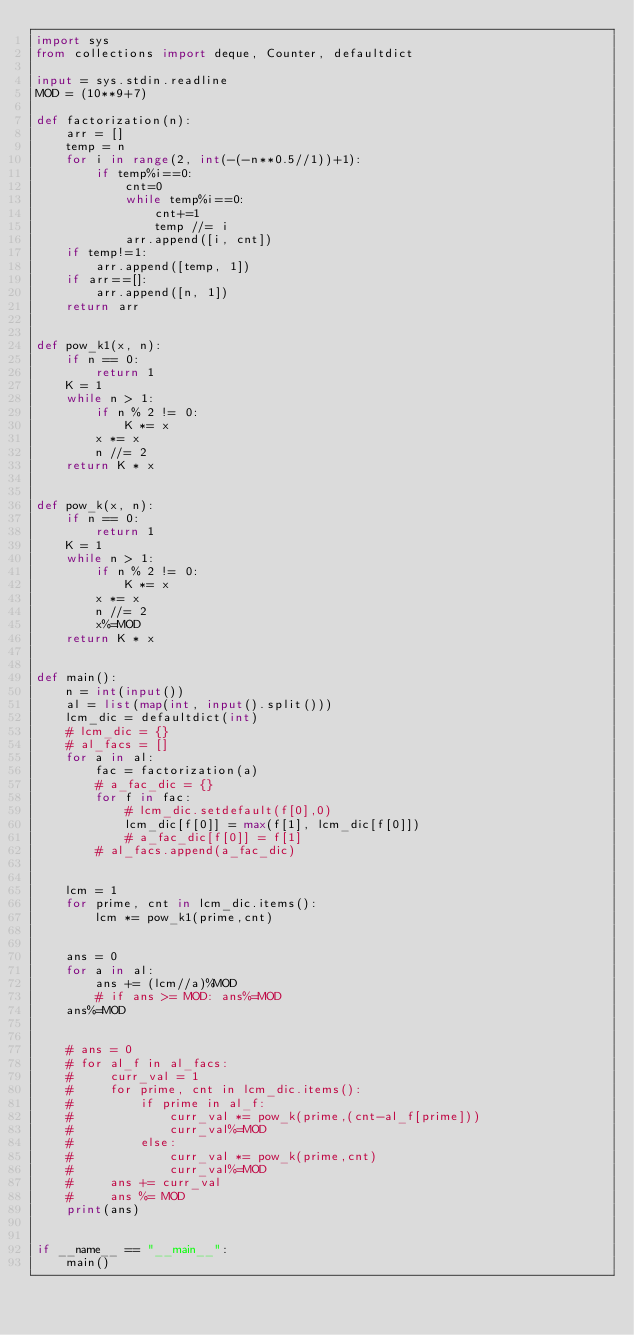<code> <loc_0><loc_0><loc_500><loc_500><_Python_>import sys
from collections import deque, Counter, defaultdict

input = sys.stdin.readline
MOD = (10**9+7)

def factorization(n):
    arr = []
    temp = n
    for i in range(2, int(-(-n**0.5//1))+1):
        if temp%i==0:
            cnt=0
            while temp%i==0:
                cnt+=1
                temp //= i
            arr.append([i, cnt])
    if temp!=1:
        arr.append([temp, 1])
    if arr==[]:
        arr.append([n, 1])
    return arr


def pow_k1(x, n):
    if n == 0:
        return 1
    K = 1
    while n > 1:
        if n % 2 != 0:
            K *= x
        x *= x
        n //= 2
    return K * x


def pow_k(x, n):
    if n == 0:
        return 1
    K = 1
    while n > 1:
        if n % 2 != 0:
            K *= x
        x *= x
        n //= 2
        x%=MOD
    return K * x


def main():
    n = int(input())
    al = list(map(int, input().split())) 
    lcm_dic = defaultdict(int)
    # lcm_dic = {}
    # al_facs = []
    for a in al:
        fac = factorization(a)
        # a_fac_dic = {}
        for f in fac:
            # lcm_dic.setdefault(f[0],0)
            lcm_dic[f[0]] = max(f[1], lcm_dic[f[0]])
            # a_fac_dic[f[0]] = f[1]
        # al_facs.append(a_fac_dic)


    lcm = 1
    for prime, cnt in lcm_dic.items():
        lcm *= pow_k1(prime,cnt)

    
    ans = 0
    for a in al:
        ans += (lcm//a)%MOD
        # if ans >= MOD: ans%=MOD
    ans%=MOD


    # ans = 0
    # for al_f in al_facs:
    #     curr_val = 1
    #     for prime, cnt in lcm_dic.items():
    #         if prime in al_f:
    #             curr_val *= pow_k(prime,(cnt-al_f[prime]))
    #             curr_val%=MOD
    #         else:
    #             curr_val *= pow_k(prime,cnt)
    #             curr_val%=MOD
    #     ans += curr_val
    #     ans %= MOD
    print(ans)


if __name__ == "__main__":
    main()</code> 